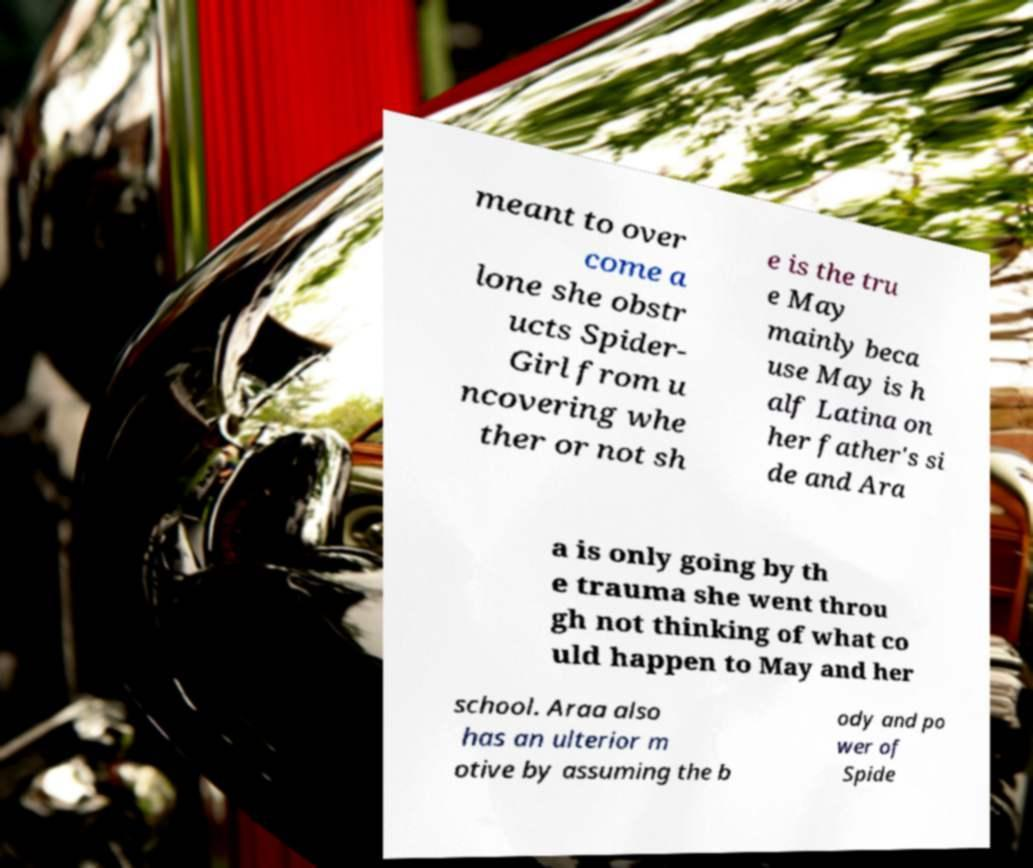Could you extract and type out the text from this image? meant to over come a lone she obstr ucts Spider- Girl from u ncovering whe ther or not sh e is the tru e May mainly beca use May is h alf Latina on her father's si de and Ara a is only going by th e trauma she went throu gh not thinking of what co uld happen to May and her school. Araa also has an ulterior m otive by assuming the b ody and po wer of Spide 